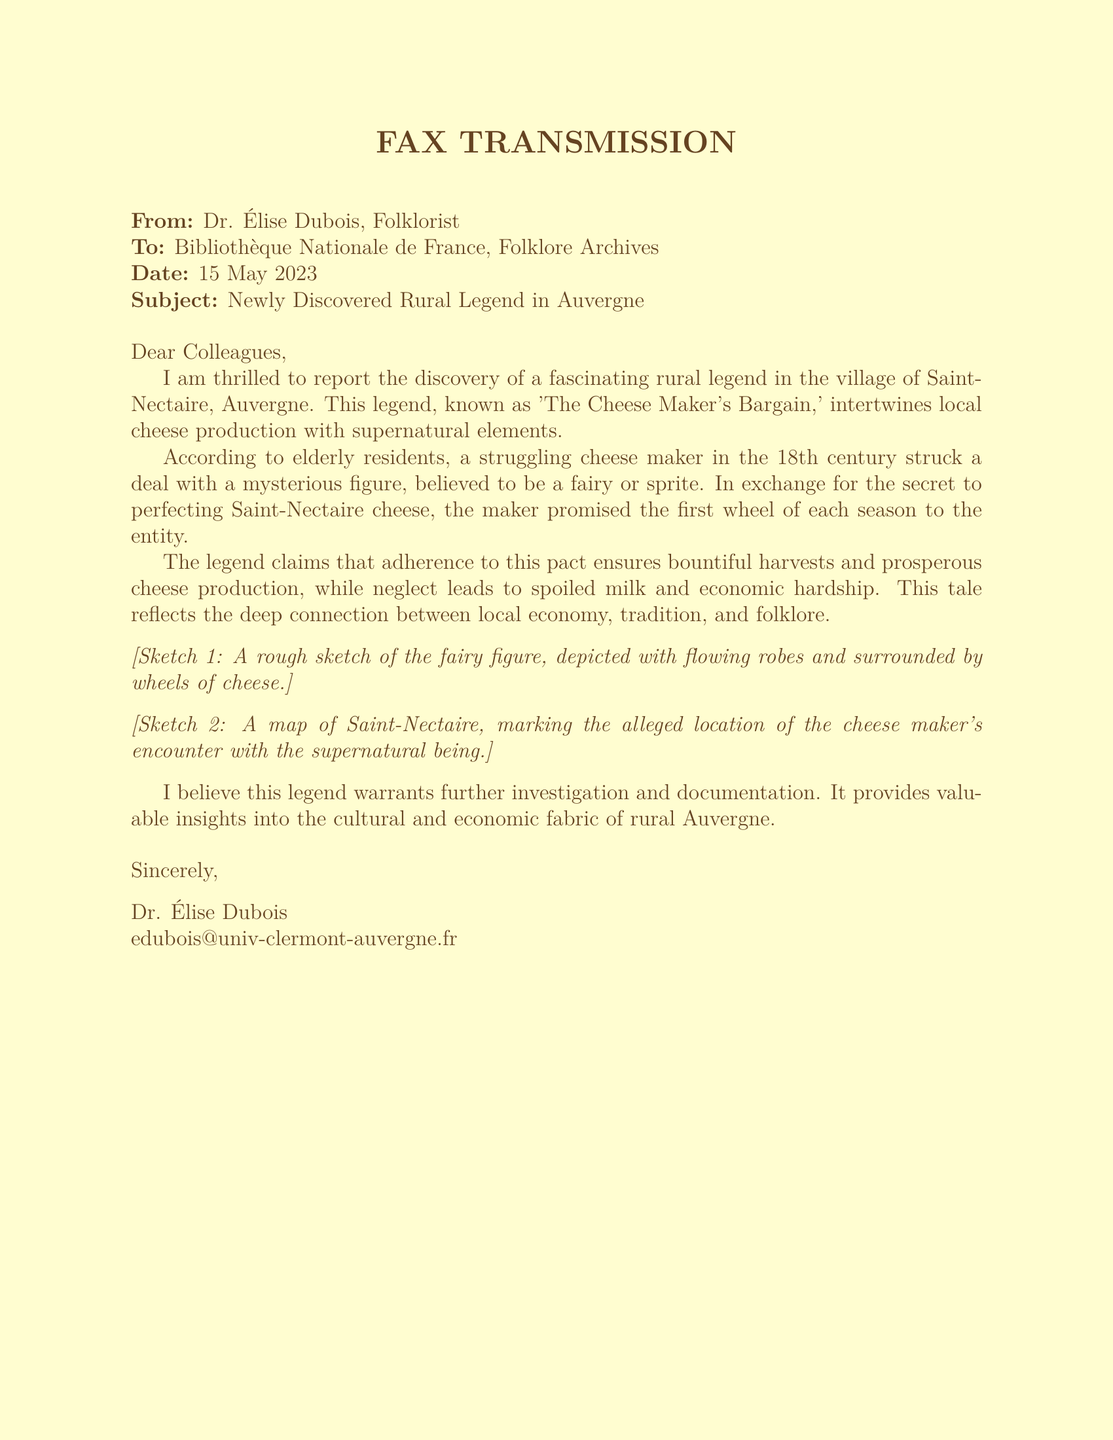What is the subject of the fax? The subject line in the fax indicates the main topic of the communication, which is the discovery of a rural legend.
Answer: Newly Discovered Rural Legend in Auvergne Who is the sender of the fax? The first line of the fax provides the name of the person who sent the document.
Answer: Dr. Élise Dubois What is the name of the legend mentioned? The text describes a specific rural legend and provides its title.
Answer: The Cheese Maker's Bargain What century does the legend originate from? The document mentions the time period when the events of the legend took place.
Answer: 18th century What does the cheese maker promise to the mysterious figure? The content reveals what the cheese maker agrees to give in exchange for the secret.
Answer: The first wheel of each season What economic impact does neglecting the pact have? The document discusses the consequences of failing to adhere to the legend's pact.
Answer: Economic hardship Where is the village mentioned in the legend located? The text states the geographical location of the legend's origin.
Answer: Saint-Nectaire What type of being is involved in the legend? The description includes the nature of the mysterious figure that the cheese maker encounters.
Answer: Fairy or sprite What are the two sketches illustrating? The fax notes what the included sketches depict related to the legend.
Answer: A fairy figure and a map of Saint-Nectaire 